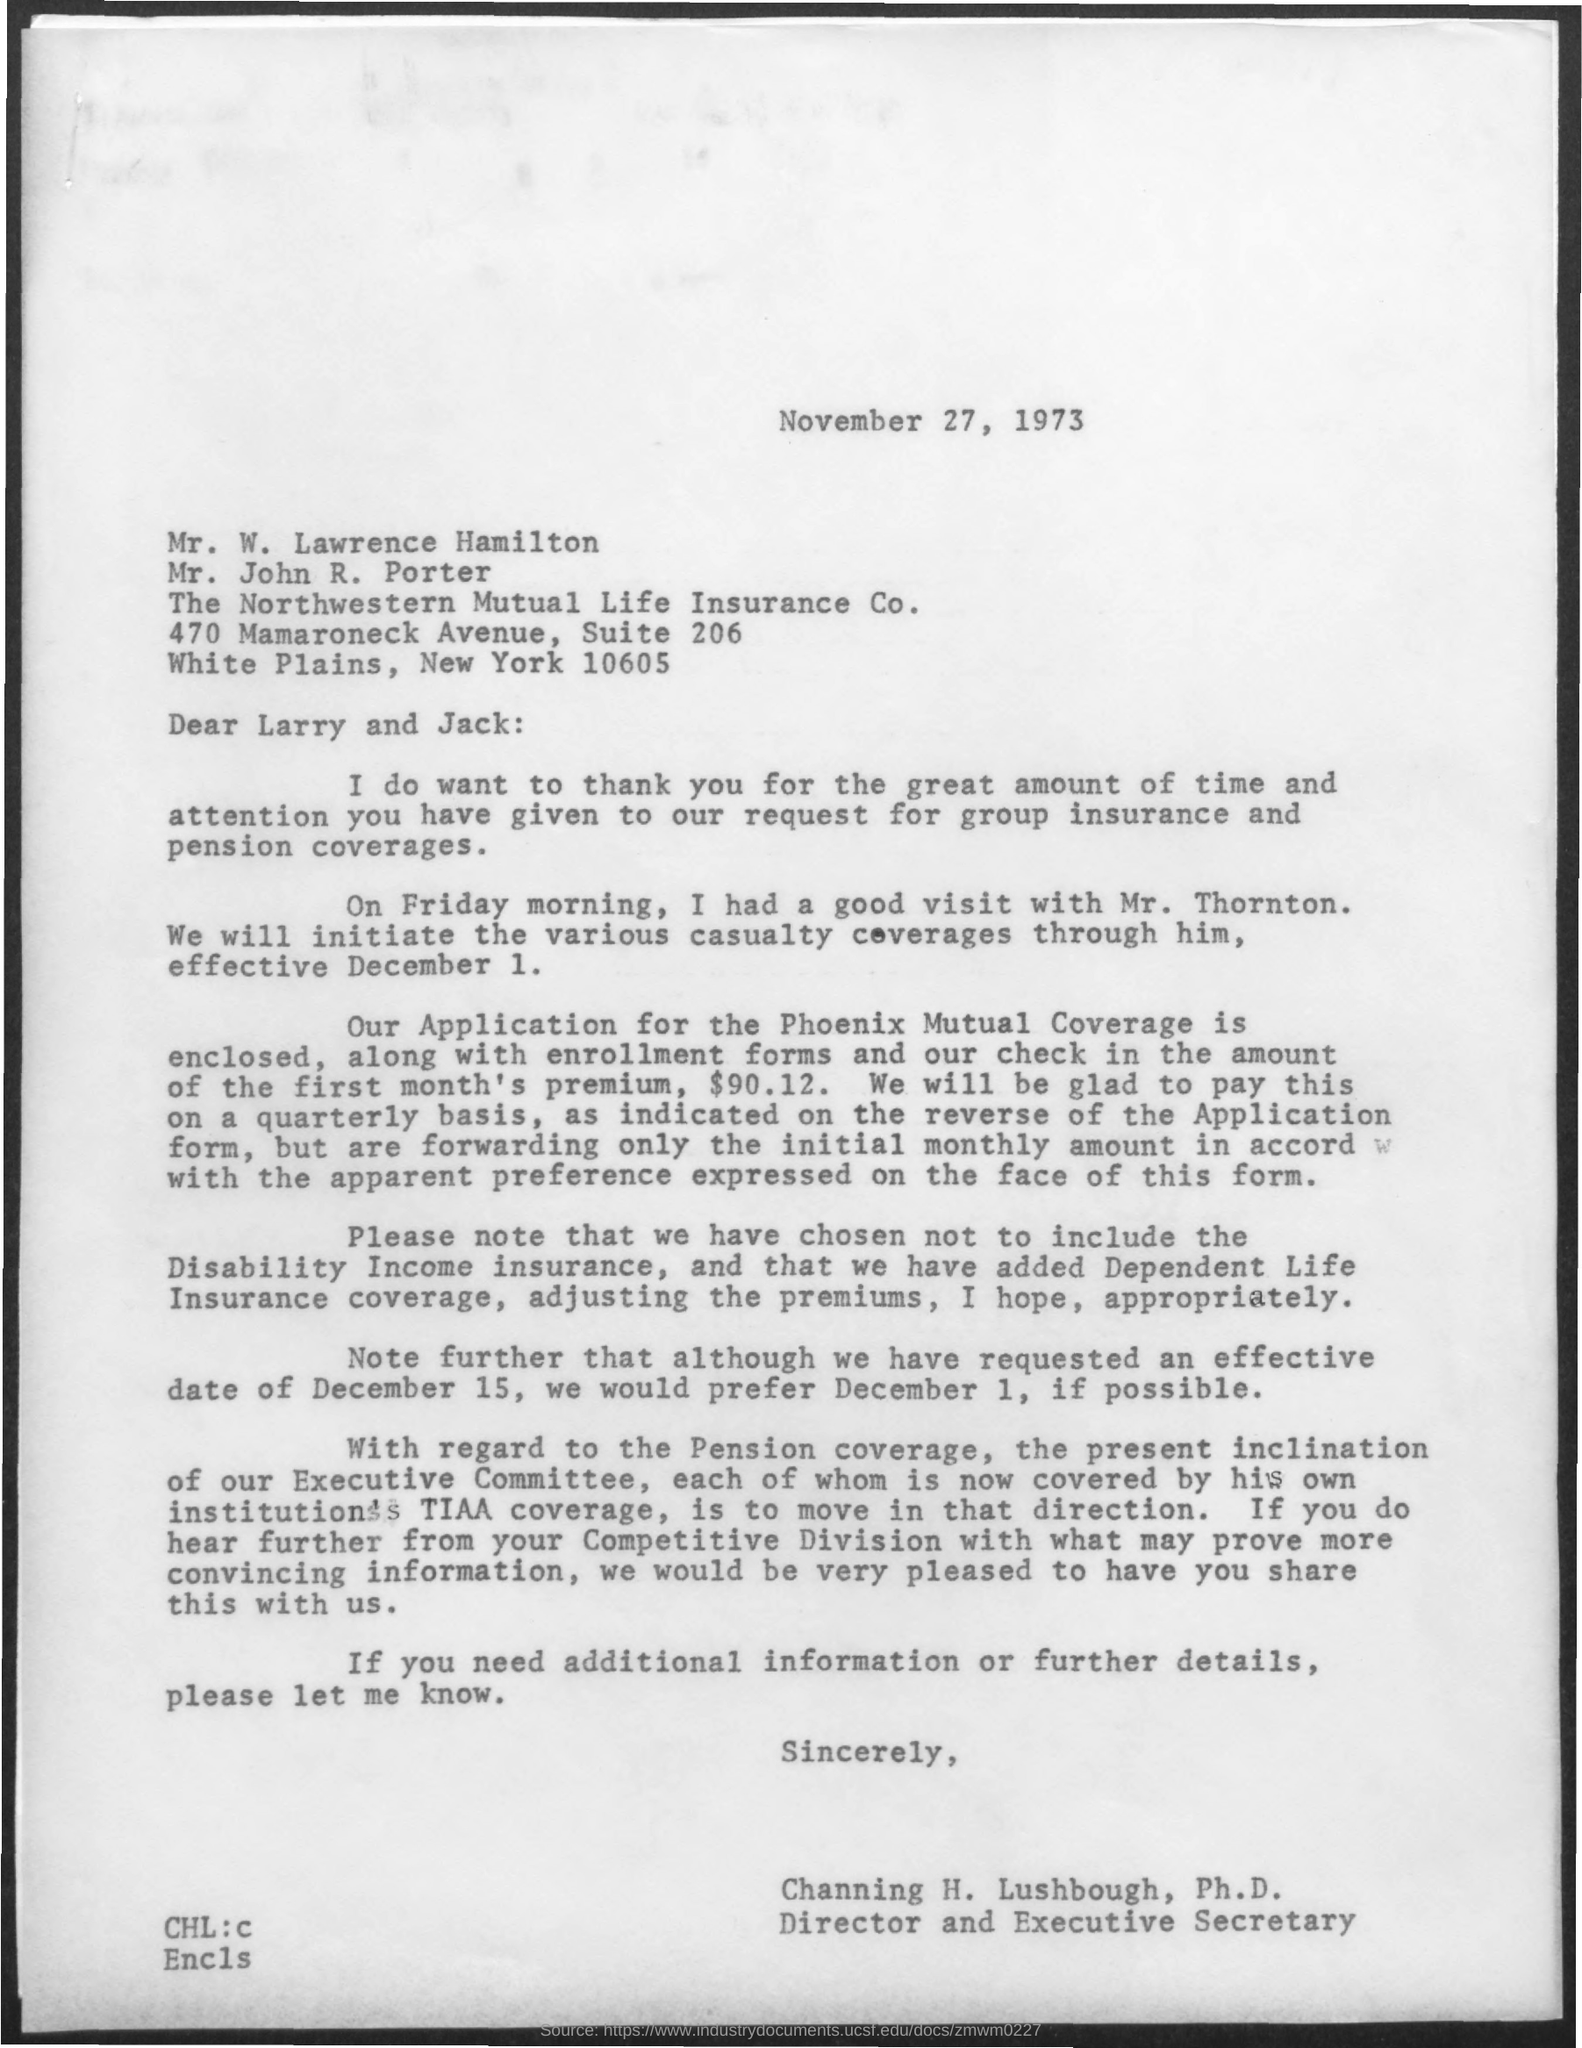List a handful of essential elements in this visual. Channing H. Lushbough holds the designation of Director and Executive Secretary. The letter was written to Larry and Jack. The individuals, Lawrence Hamilton and Porter, belong to the Northwestern Mutual Life Insurance Company. The date mentioned in the given letter is November 27, 1973. 